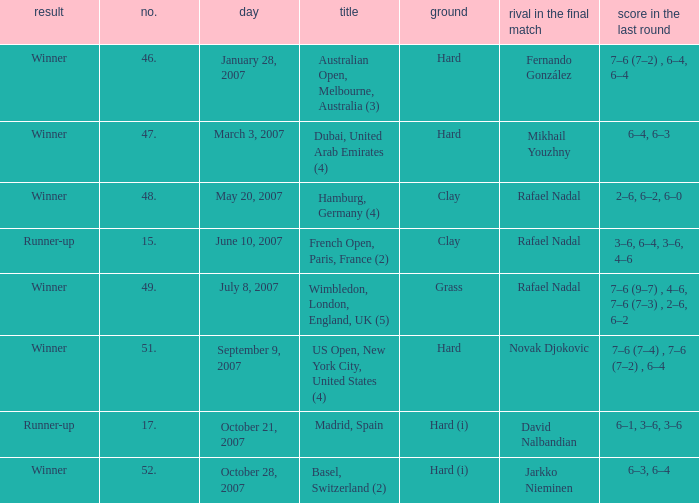Where the outcome is Winner and surface is Hard (i), what is the No.? 52.0. 